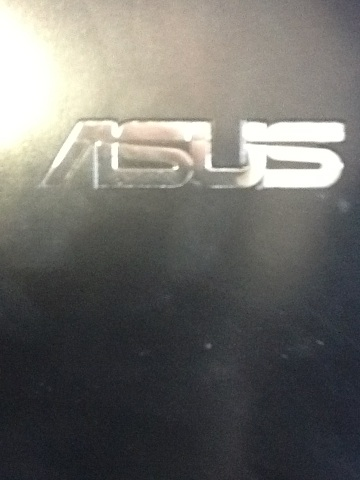Describe a scenario where this logo might be seen in a real-world setting. This logo might be seen in a modern office setting, attached to a sleek Asus laptop that a software developer is using to write and compile code. The developer relies on its high-performance specifications to run multiple virtual machines and manage complex, resource-intensive tasks. The laptop's sharp and vibrant screen displays various coding environments, and its robust build allows the developer to carry it effortlessly between offices and meetings. 